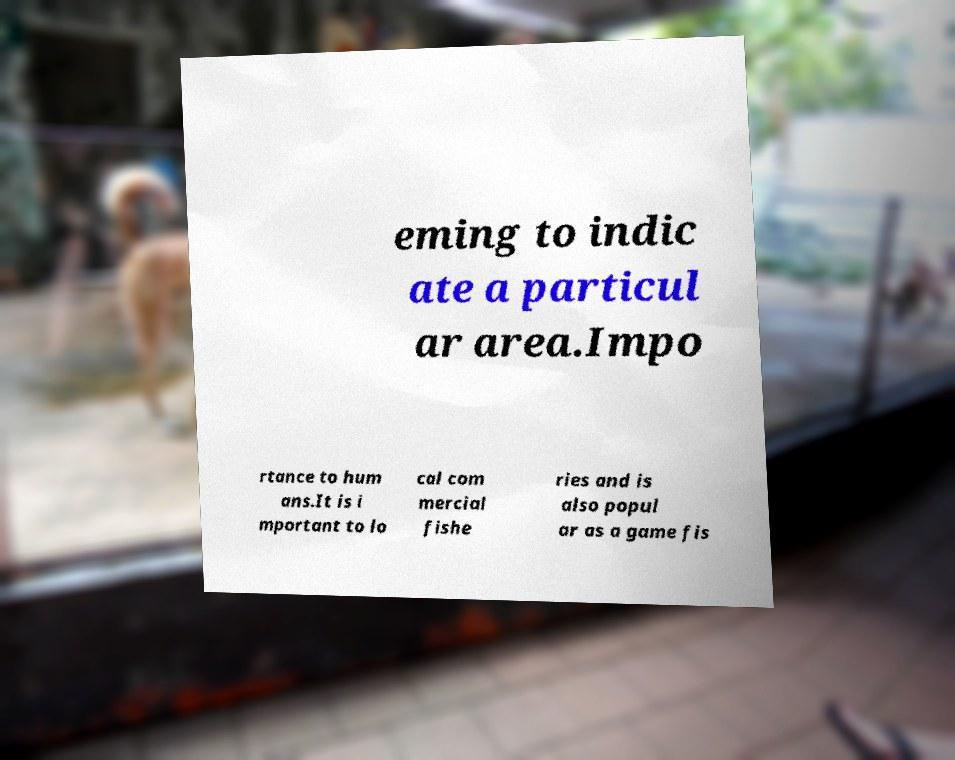What messages or text are displayed in this image? I need them in a readable, typed format. eming to indic ate a particul ar area.Impo rtance to hum ans.It is i mportant to lo cal com mercial fishe ries and is also popul ar as a game fis 